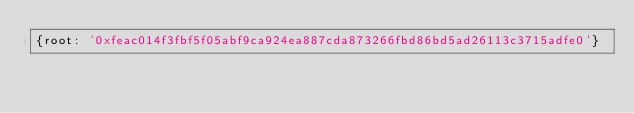Convert code to text. <code><loc_0><loc_0><loc_500><loc_500><_YAML_>{root: '0xfeac014f3fbf5f05abf9ca924ea887cda873266fbd86bd5ad26113c3715adfe0'}
</code> 